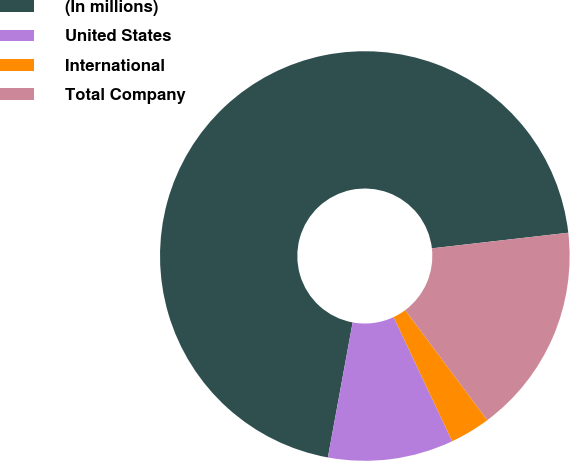<chart> <loc_0><loc_0><loc_500><loc_500><pie_chart><fcel>(In millions)<fcel>United States<fcel>International<fcel>Total Company<nl><fcel>70.3%<fcel>9.9%<fcel>3.19%<fcel>16.61%<nl></chart> 